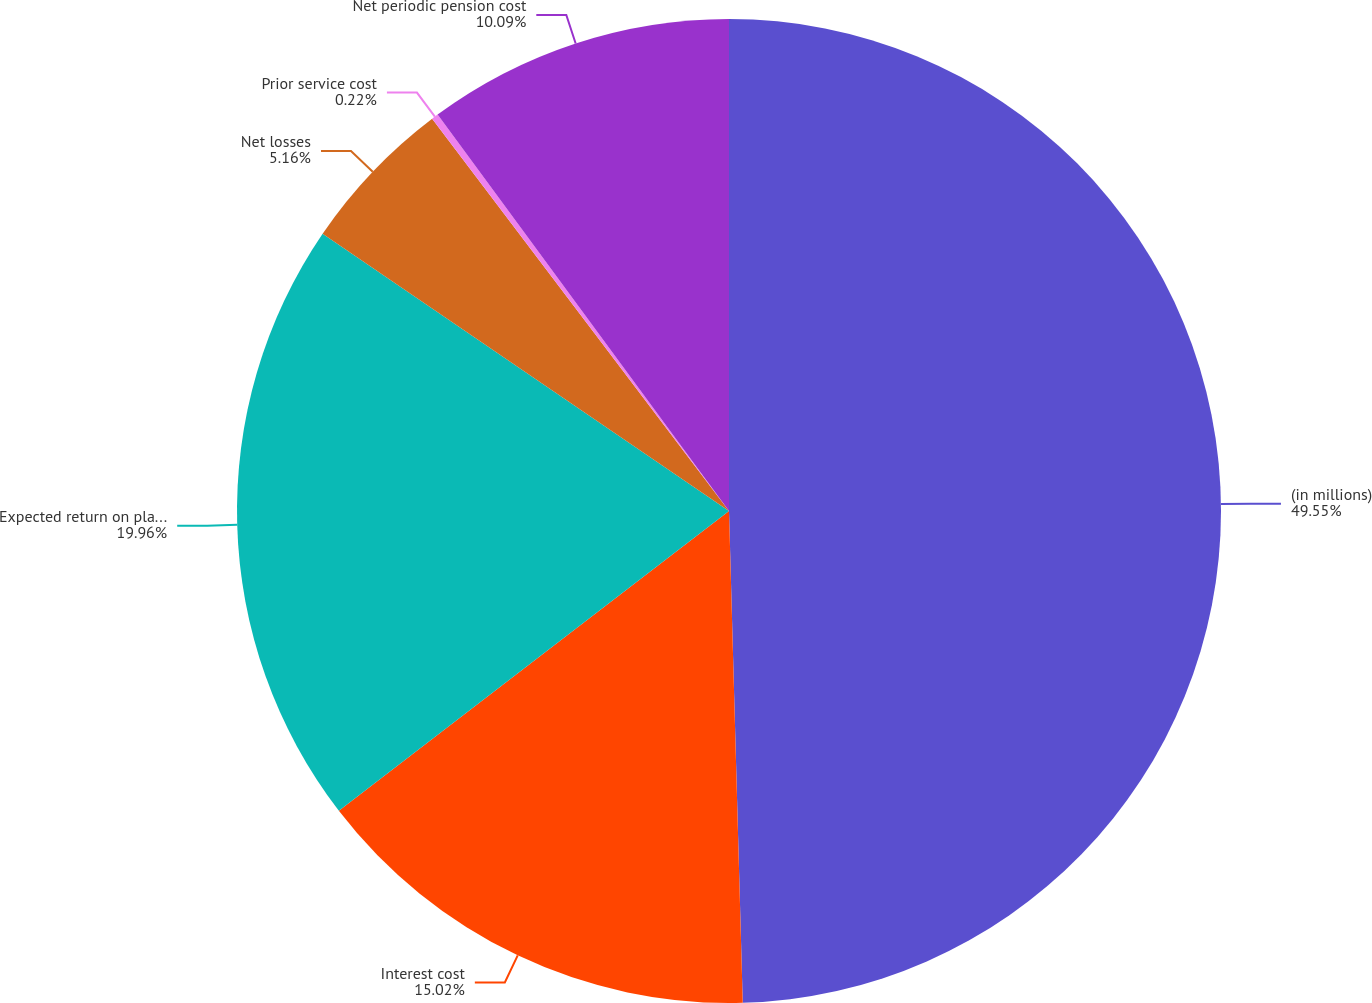Convert chart. <chart><loc_0><loc_0><loc_500><loc_500><pie_chart><fcel>(in millions)<fcel>Interest cost<fcel>Expected return on plan assets<fcel>Net losses<fcel>Prior service cost<fcel>Net periodic pension cost<nl><fcel>49.56%<fcel>15.02%<fcel>19.96%<fcel>5.16%<fcel>0.22%<fcel>10.09%<nl></chart> 